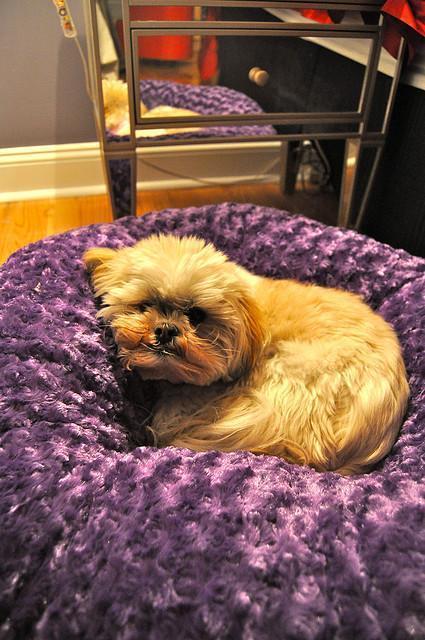How many boat on the seasore?
Give a very brief answer. 0. 